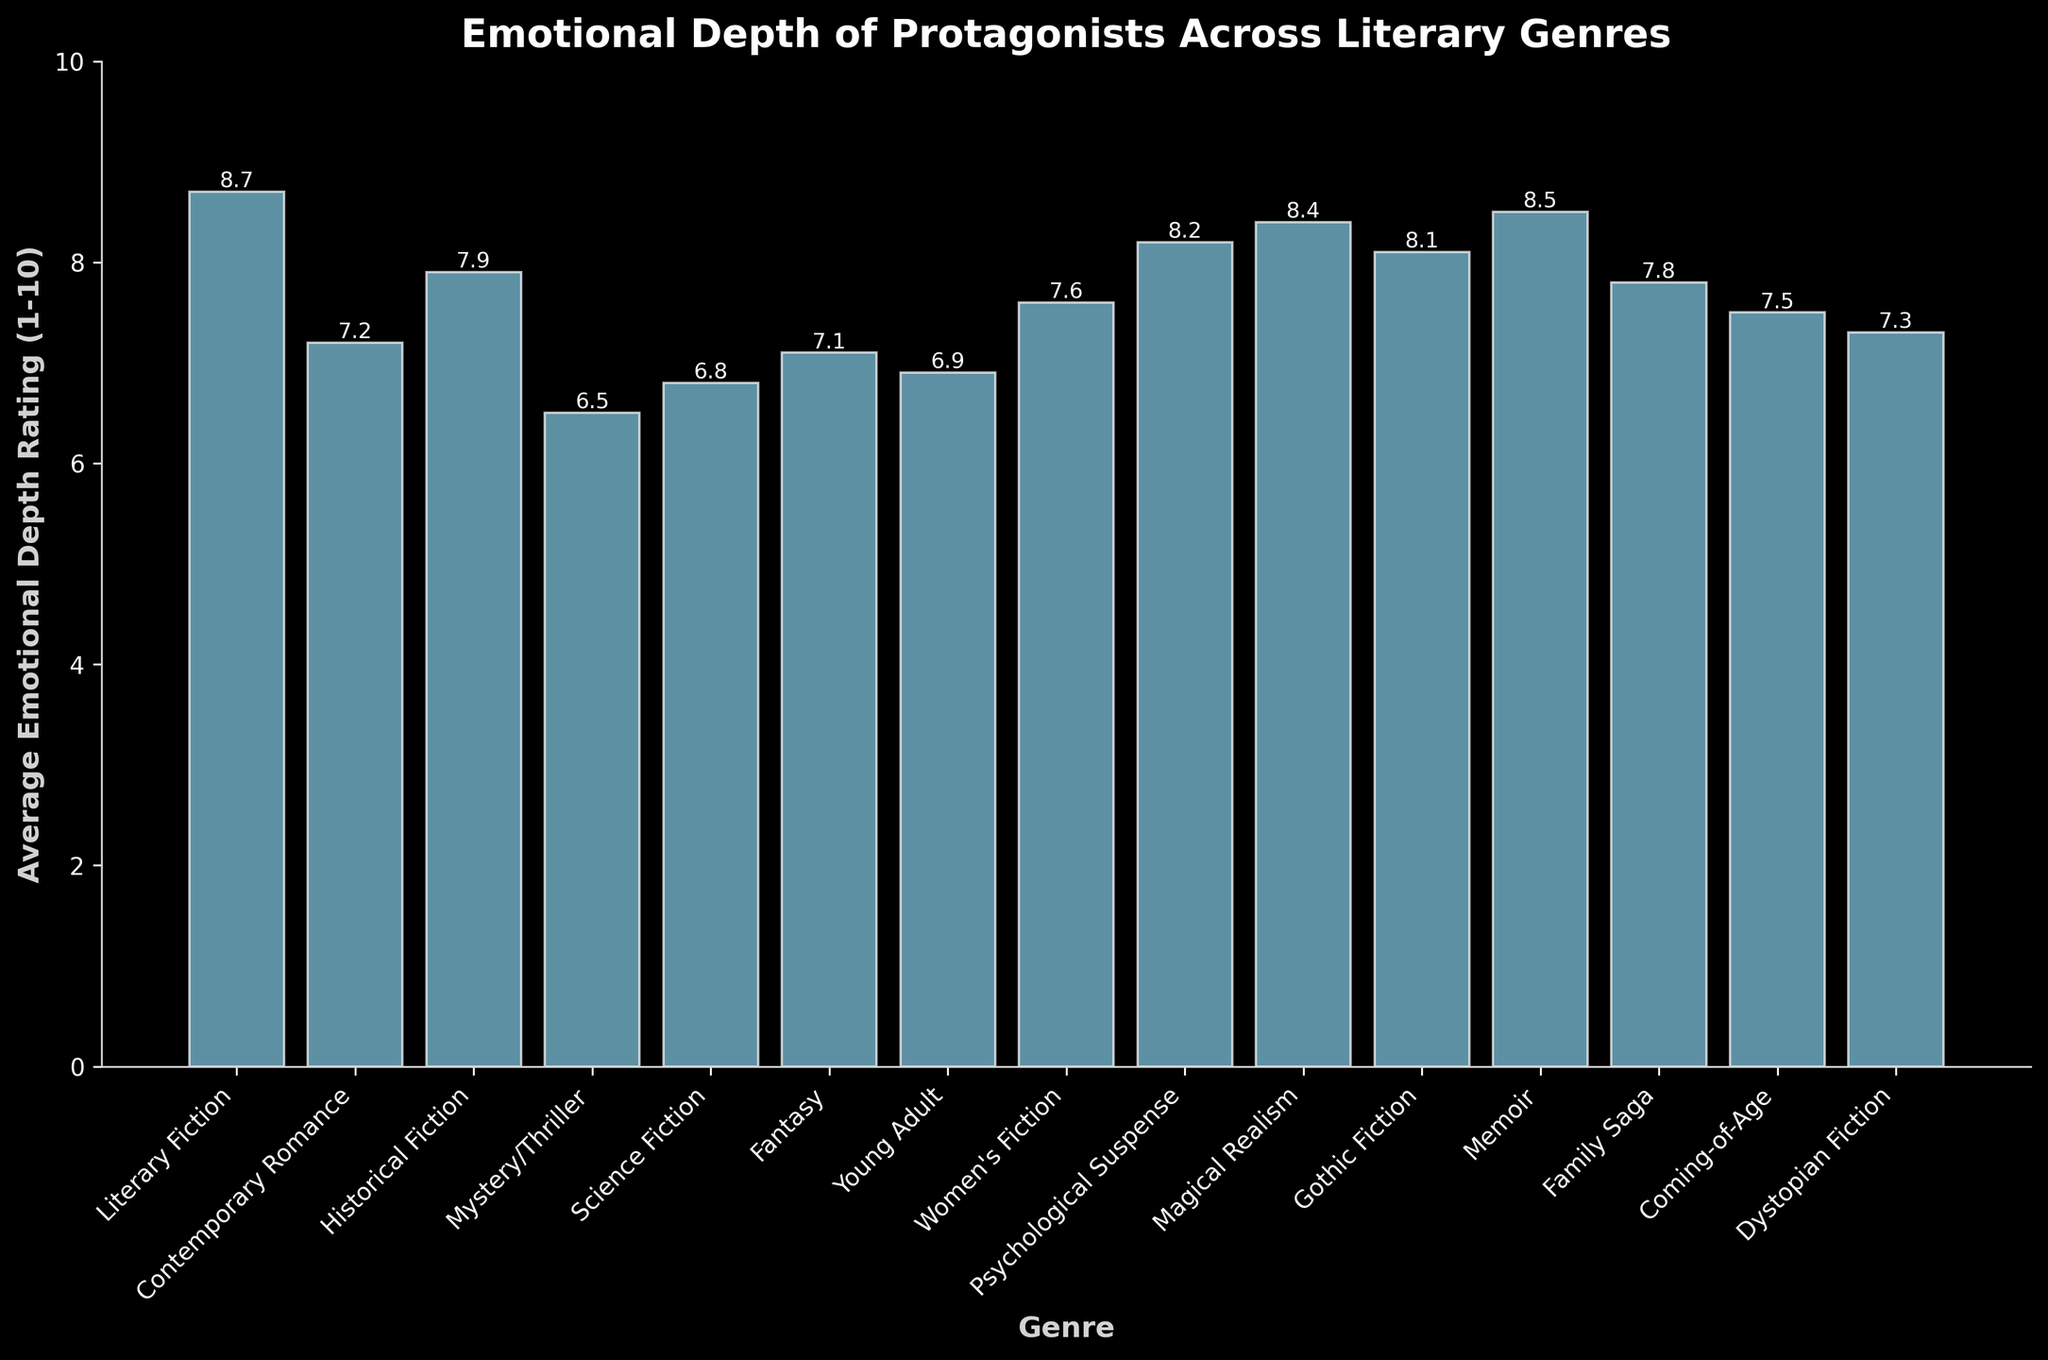Which genre has the highest average emotional depth rating? The genre with the highest average emotional depth rating has the tallest bar. By examining the heights, the highest bar represents Literary Fiction.
Answer: Literary Fiction Which genres have an average emotional depth rating greater than 8? To answer this, check which bars exceed the 8 mark on the y-axis. These genres are Literary Fiction, Memoir, Magical Realism, and Psychological Suspense.
Answer: Literary Fiction, Memoir, Magical Realism, Psychological Suspense What is the average emotional depth rating for Young Adult? Look at the bar corresponding to Young Adult and read the value at the top of the bar. It is 6.9.
Answer: 6.9 What is the difference in average emotional depth rating between Mystery/Thriller and Women's Fiction? Find the heights of the bars for Mystery/Thriller (6.5) and Women's Fiction (7.6). Subtract the former from the latter: 7.6 - 6.5 = 1.1.
Answer: 1.1 Which genre has a higher average emotional depth rating: Fantasy or Historical Fiction? Compare the heights of the bars for Fantasy (7.1) and Historical Fiction (7.9). Historical Fiction is taller.
Answer: Historical Fiction What is the combined average emotional depth rating of Science Fiction, Dystopian Fiction, and Gothic Fiction? Add the values at the top of the bars for Science Fiction (6.8), Dystopian Fiction (7.3), and Gothic Fiction (8.1). The sum is 6.8 + 7.3 + 8.1 = 22.2.
Answer: 22.2 Is the average emotional depth rating of Coming-of-Age more than that of Contemporary Romance? Compare the heights of the bars for Coming-of-Age (7.5) and Contemporary Romance (7.2). 7.5 is greater than 7.2.
Answer: Yes Which genre has the lowest average emotional depth rating? The genre with the shortest bar has the lowest average rating. The shortest bar represents Mystery/Thriller.
Answer: Mystery/Thriller How many genres have an average emotional depth rating between 7 and 8? Count the bars that fall between the 7 and 8 marks on the y-axis. These genres are Contemporary Romance, Fantasy, Young Adult, Women's Fiction, Family Saga, and Coming-of-Age. There are 6.
Answer: 6 